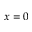<formula> <loc_0><loc_0><loc_500><loc_500>x = 0</formula> 